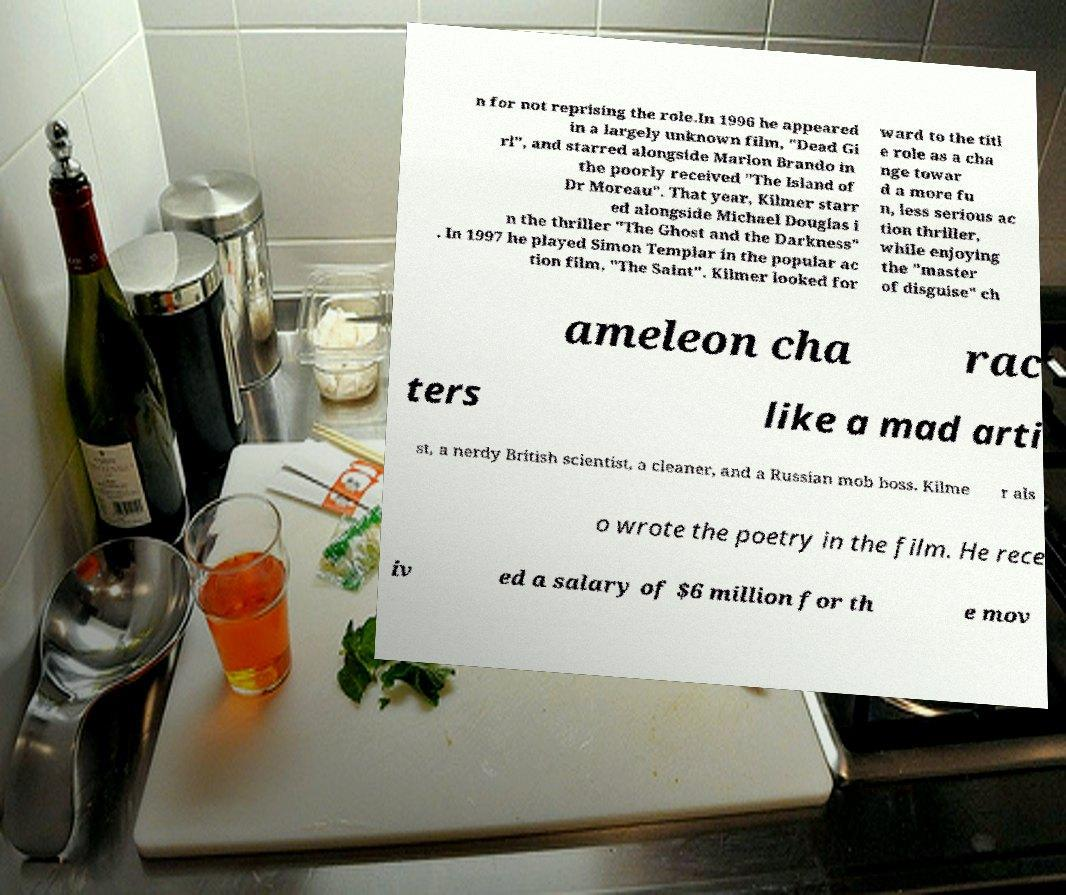What messages or text are displayed in this image? I need them in a readable, typed format. n for not reprising the role.In 1996 he appeared in a largely unknown film, "Dead Gi rl", and starred alongside Marlon Brando in the poorly received "The Island of Dr Moreau". That year, Kilmer starr ed alongside Michael Douglas i n the thriller "The Ghost and the Darkness" . In 1997 he played Simon Templar in the popular ac tion film, "The Saint". Kilmer looked for ward to the titl e role as a cha nge towar d a more fu n, less serious ac tion thriller, while enjoying the "master of disguise" ch ameleon cha rac ters like a mad arti st, a nerdy British scientist, a cleaner, and a Russian mob boss. Kilme r als o wrote the poetry in the film. He rece iv ed a salary of $6 million for th e mov 